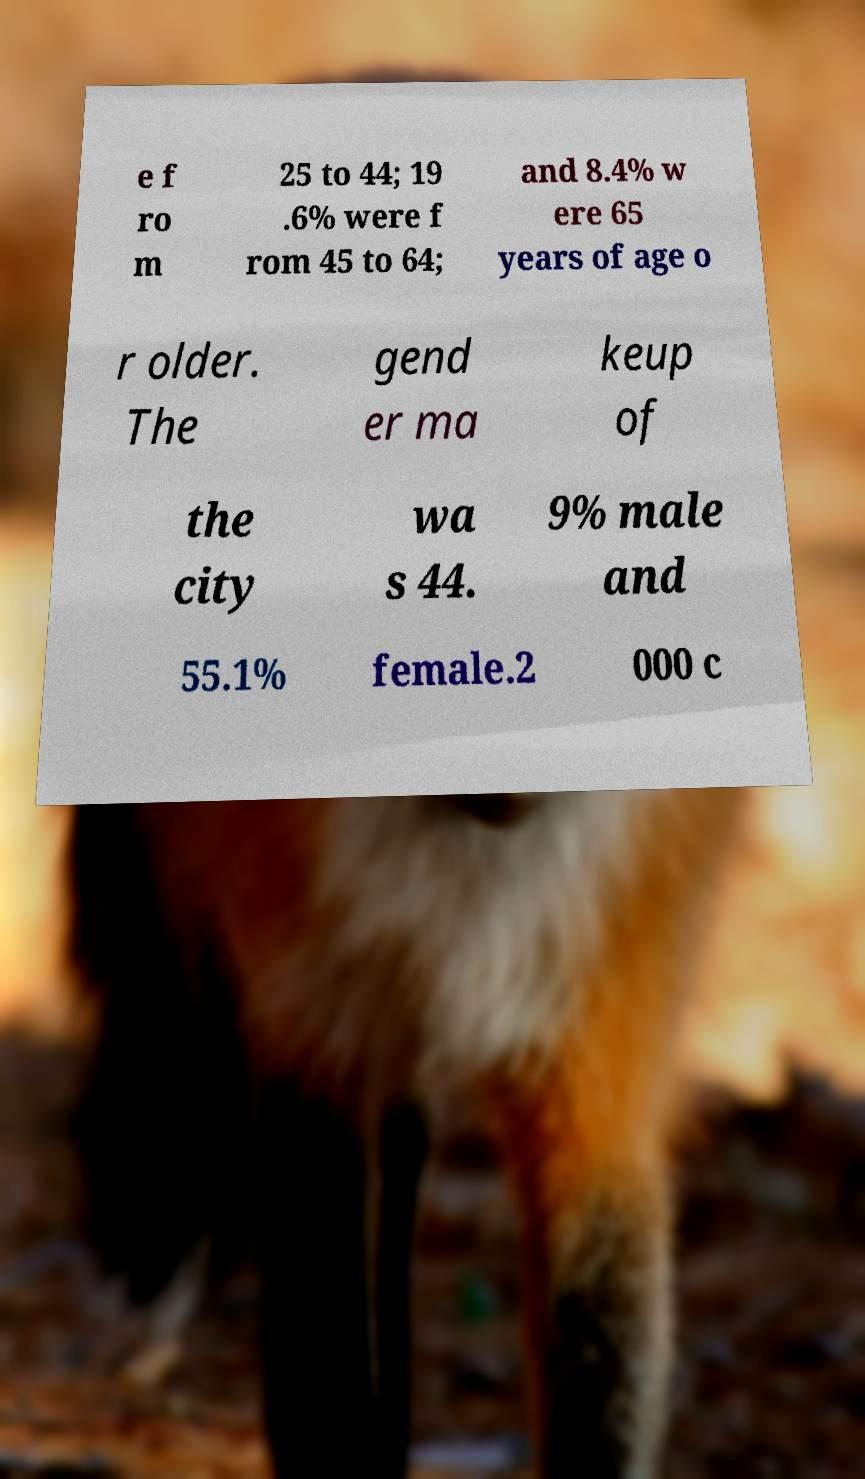Can you read and provide the text displayed in the image?This photo seems to have some interesting text. Can you extract and type it out for me? e f ro m 25 to 44; 19 .6% were f rom 45 to 64; and 8.4% w ere 65 years of age o r older. The gend er ma keup of the city wa s 44. 9% male and 55.1% female.2 000 c 